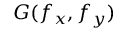Convert formula to latex. <formula><loc_0><loc_0><loc_500><loc_500>G ( f _ { x } , f _ { y } )</formula> 